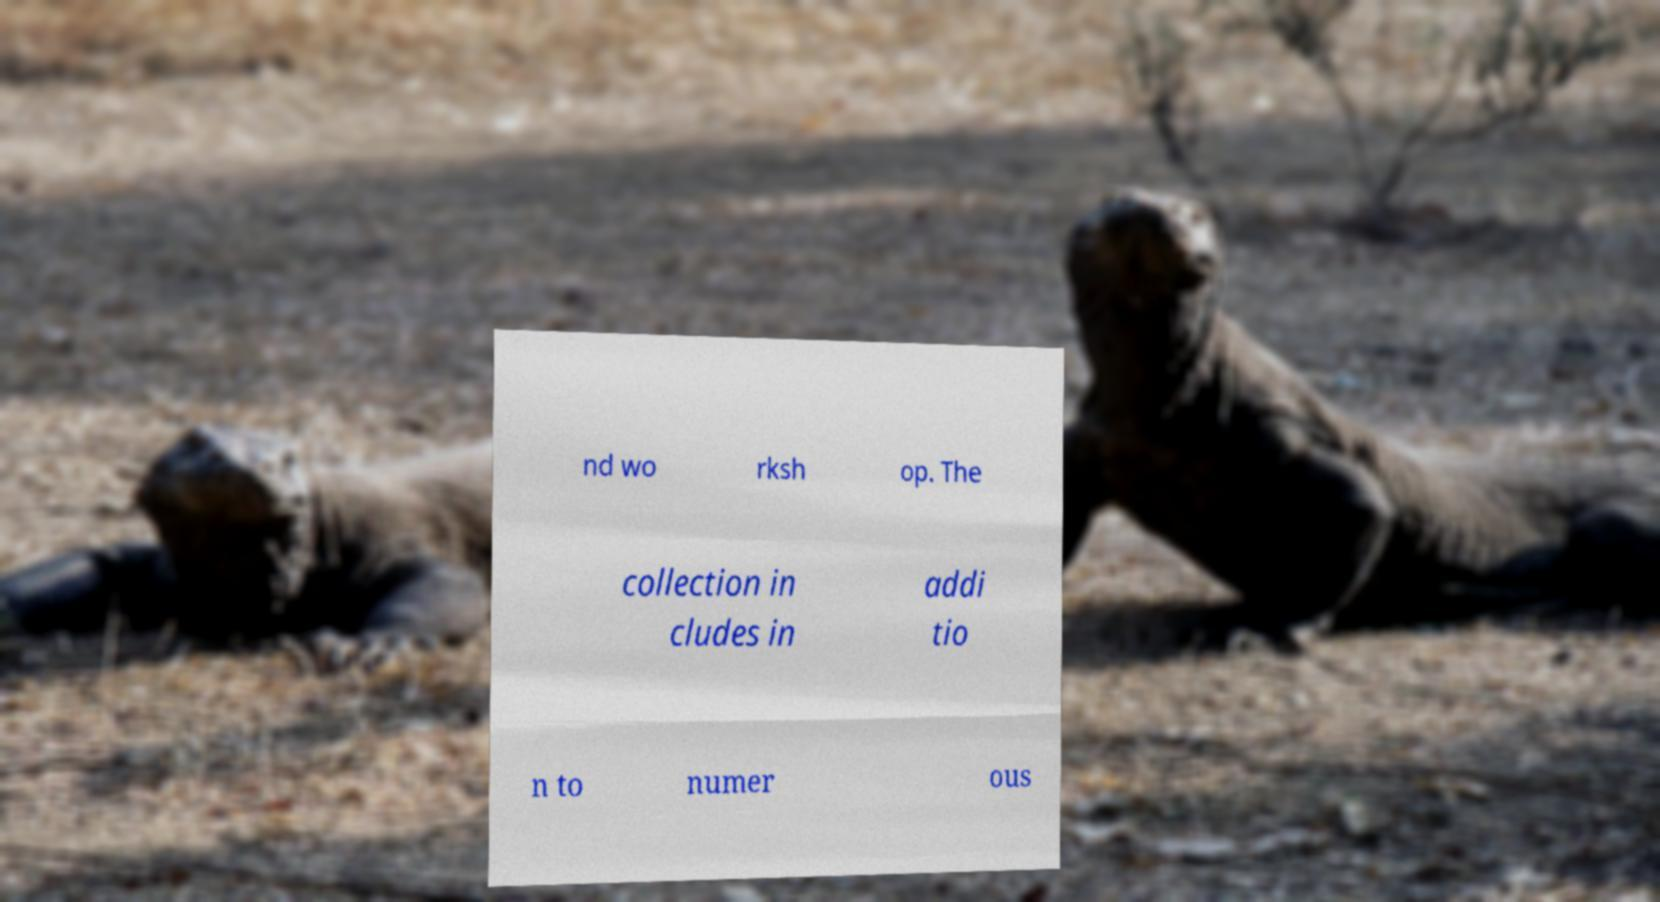Please identify and transcribe the text found in this image. nd wo rksh op. The collection in cludes in addi tio n to numer ous 